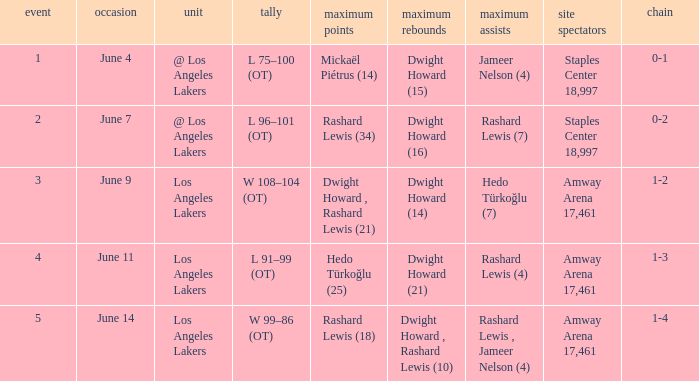Can you give me this table as a dict? {'header': ['event', 'occasion', 'unit', 'tally', 'maximum points', 'maximum rebounds', 'maximum assists', 'site spectators', 'chain'], 'rows': [['1', 'June 4', '@ Los Angeles Lakers', 'L 75–100 (OT)', 'Mickaël Piétrus (14)', 'Dwight Howard (15)', 'Jameer Nelson (4)', 'Staples Center 18,997', '0-1'], ['2', 'June 7', '@ Los Angeles Lakers', 'L 96–101 (OT)', 'Rashard Lewis (34)', 'Dwight Howard (16)', 'Rashard Lewis (7)', 'Staples Center 18,997', '0-2'], ['3', 'June 9', 'Los Angeles Lakers', 'W 108–104 (OT)', 'Dwight Howard , Rashard Lewis (21)', 'Dwight Howard (14)', 'Hedo Türkoğlu (7)', 'Amway Arena 17,461', '1-2'], ['4', 'June 11', 'Los Angeles Lakers', 'L 91–99 (OT)', 'Hedo Türkoğlu (25)', 'Dwight Howard (21)', 'Rashard Lewis (4)', 'Amway Arena 17,461', '1-3'], ['5', 'June 14', 'Los Angeles Lakers', 'W 99–86 (OT)', 'Rashard Lewis (18)', 'Dwight Howard , Rashard Lewis (10)', 'Rashard Lewis , Jameer Nelson (4)', 'Amway Arena 17,461', '1-4']]} What is High Points, when High Rebounds is "Dwight Howard (16)"? Rashard Lewis (34). 